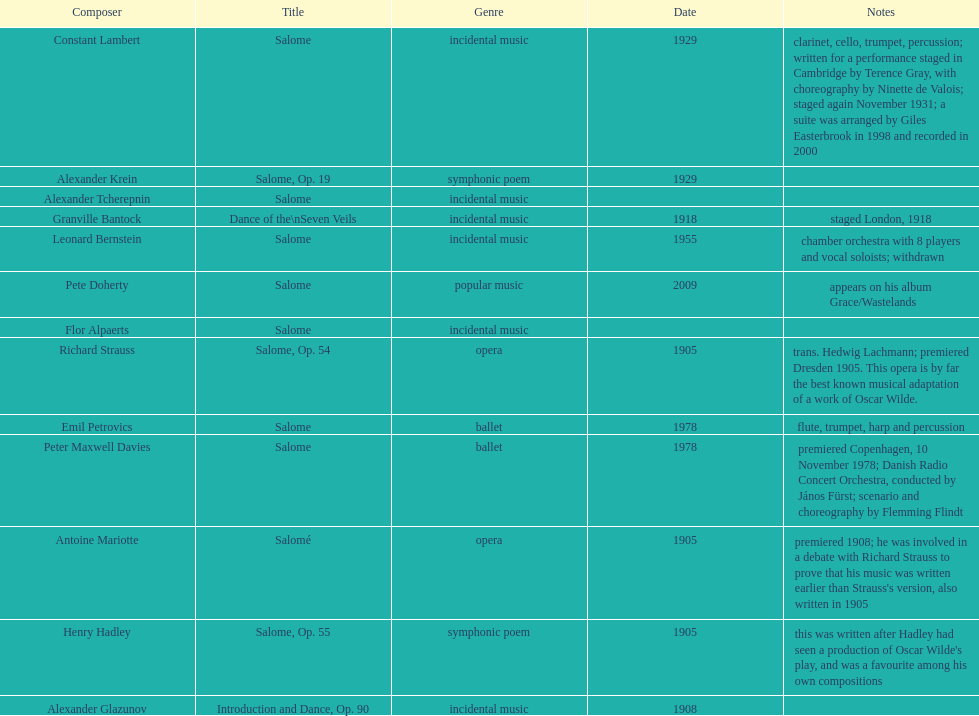What was the work authored by henry hadley following his experience of an oscar wilde play? Salome, Op. 55. 